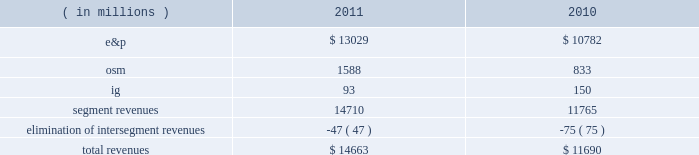2022 increased proved liquid hydrocarbon , including synthetic crude oil , reserves to 78 percent from 75 percent of proved reserves 2022 increased e&p net sales volumes , excluding libya , by 7 percent 2022 recorded 96 percent average operational availability for all major company-operated e&p assets , compared to 94 percent in 2010 2022 completed debottlenecking work that increased crude oil production capacity at the alvheim fpso in norway to 150000 gross bbld from the previous capacity of 142000 gross bbld and the original 2008 capacity of 120000 gross bbld 2022 announced two non-operated discoveries in the iraqi kurdistan region and began drilling in poland 2022 completed aosp expansion 1 , including the start-up of the expanded scotford upgrader , realizing an increase in net synthetic crude oil sales volumes of 48 percent 2022 completed dispositions of non-core assets and interests in acreage positions for net proceeds of $ 518 million 2022 repurchased 12 million shares of our common stock at a cost of $ 300 million 2022 retired $ 2498 million principal of our long-term debt 2022 resumed limited production in libya in the fourth quarter of 2011 following the february 2011 temporary suspension of operations consolidated results of operations : 2011 compared to 2010 due to the spin-off of our downstream business on june 30 , 2011 , which is reported as discontinued operations , income from continuing operations is more representative of marathon oil as an independent energy company .
Consolidated income from continuing operations before income taxes was 9 percent higher in 2011 than in 2010 , largely due to higher liquid hydrocarbon prices .
This improvement was offset by increased income taxes primarily the result of excess foreign tax credits generated during 2011 that we do not expect to utilize in the future .
The effective income tax rate for continuing operations was 61 percent in 2011 compared to 54 percent in 2010 .
Revenues are summarized in the table : ( in millions ) 2011 2010 .
E&p segment revenues increased $ 2247 million from 2010 to 2011 , primarily due to higher average liquid hydrocarbon realizations , which were $ 99.37 per bbl in 2011 , a 31 percent increase over 2010 .
Revenues in 2010 included net pre-tax gains of $ 95 million on derivative instruments intended to mitigate price risk on future sales of liquid hydrocarbons and natural gas .
Included in our e&p segment are supply optimization activities which include the purchase of commodities from third parties for resale .
Supply optimization serves to aggregate volumes in order to satisfy transportation commitments and to achieve flexibility within product types and delivery points .
See the cost of revenues discussion as revenues from supply optimization approximate the related costs .
Higher average crude oil prices in 2011 compared to 2010 increased revenues related to supply optimization .
Revenues from the sale of our u.s .
Production are higher in 2011 primarily as a result of higher liquid hydrocarbon and natural gas price realizations , but sales volumes declined. .
What was the total revenues for 2011 and 2010 , in millions? 
Computations: (14663 + 11690)
Answer: 26353.0. 